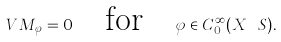Convert formula to latex. <formula><loc_0><loc_0><loc_500><loc_500>V M _ { \varphi } = 0 \quad \text {for} \quad \varphi \in C ^ { \infty } _ { 0 } ( X \ S ) .</formula> 